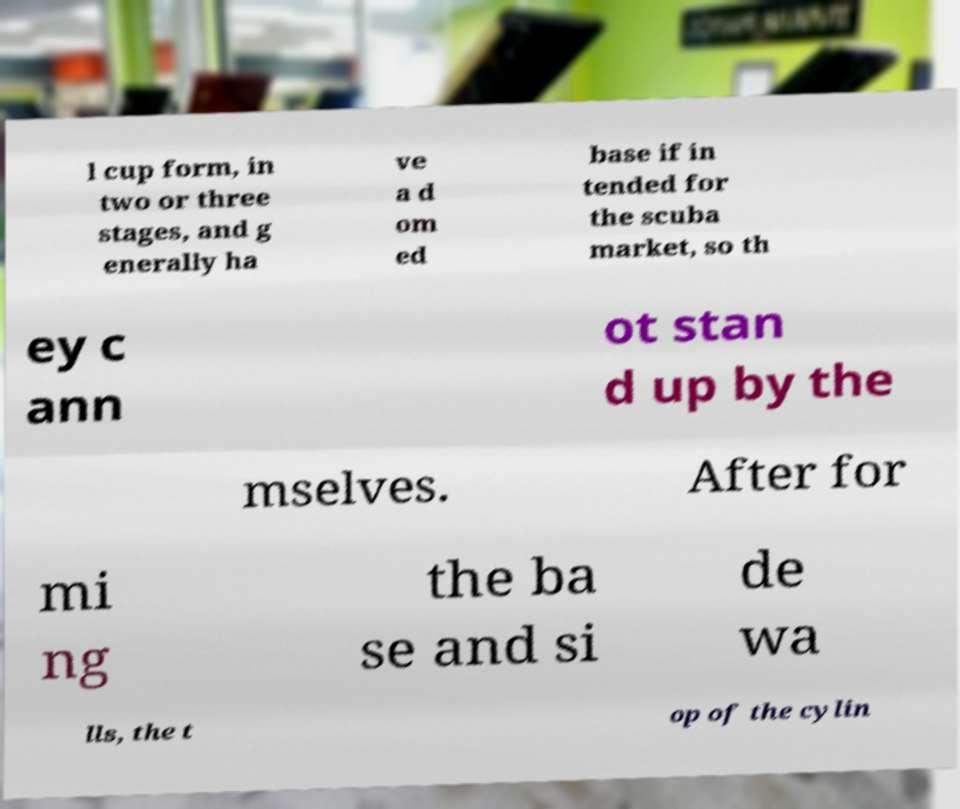I need the written content from this picture converted into text. Can you do that? l cup form, in two or three stages, and g enerally ha ve a d om ed base if in tended for the scuba market, so th ey c ann ot stan d up by the mselves. After for mi ng the ba se and si de wa lls, the t op of the cylin 